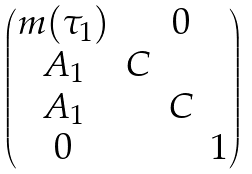Convert formula to latex. <formula><loc_0><loc_0><loc_500><loc_500>\begin{pmatrix} m ( \tau _ { 1 } ) & & 0 & \\ A _ { 1 } & C & & \\ A _ { 1 } & & C & \\ 0 & & & 1 \end{pmatrix}</formula> 